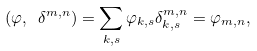<formula> <loc_0><loc_0><loc_500><loc_500>( \varphi , \ \delta ^ { m , n } ) = \sum _ { k , s } \varphi _ { k , s } \delta ^ { m , n } _ { k , s } = \varphi _ { m , n } ,</formula> 